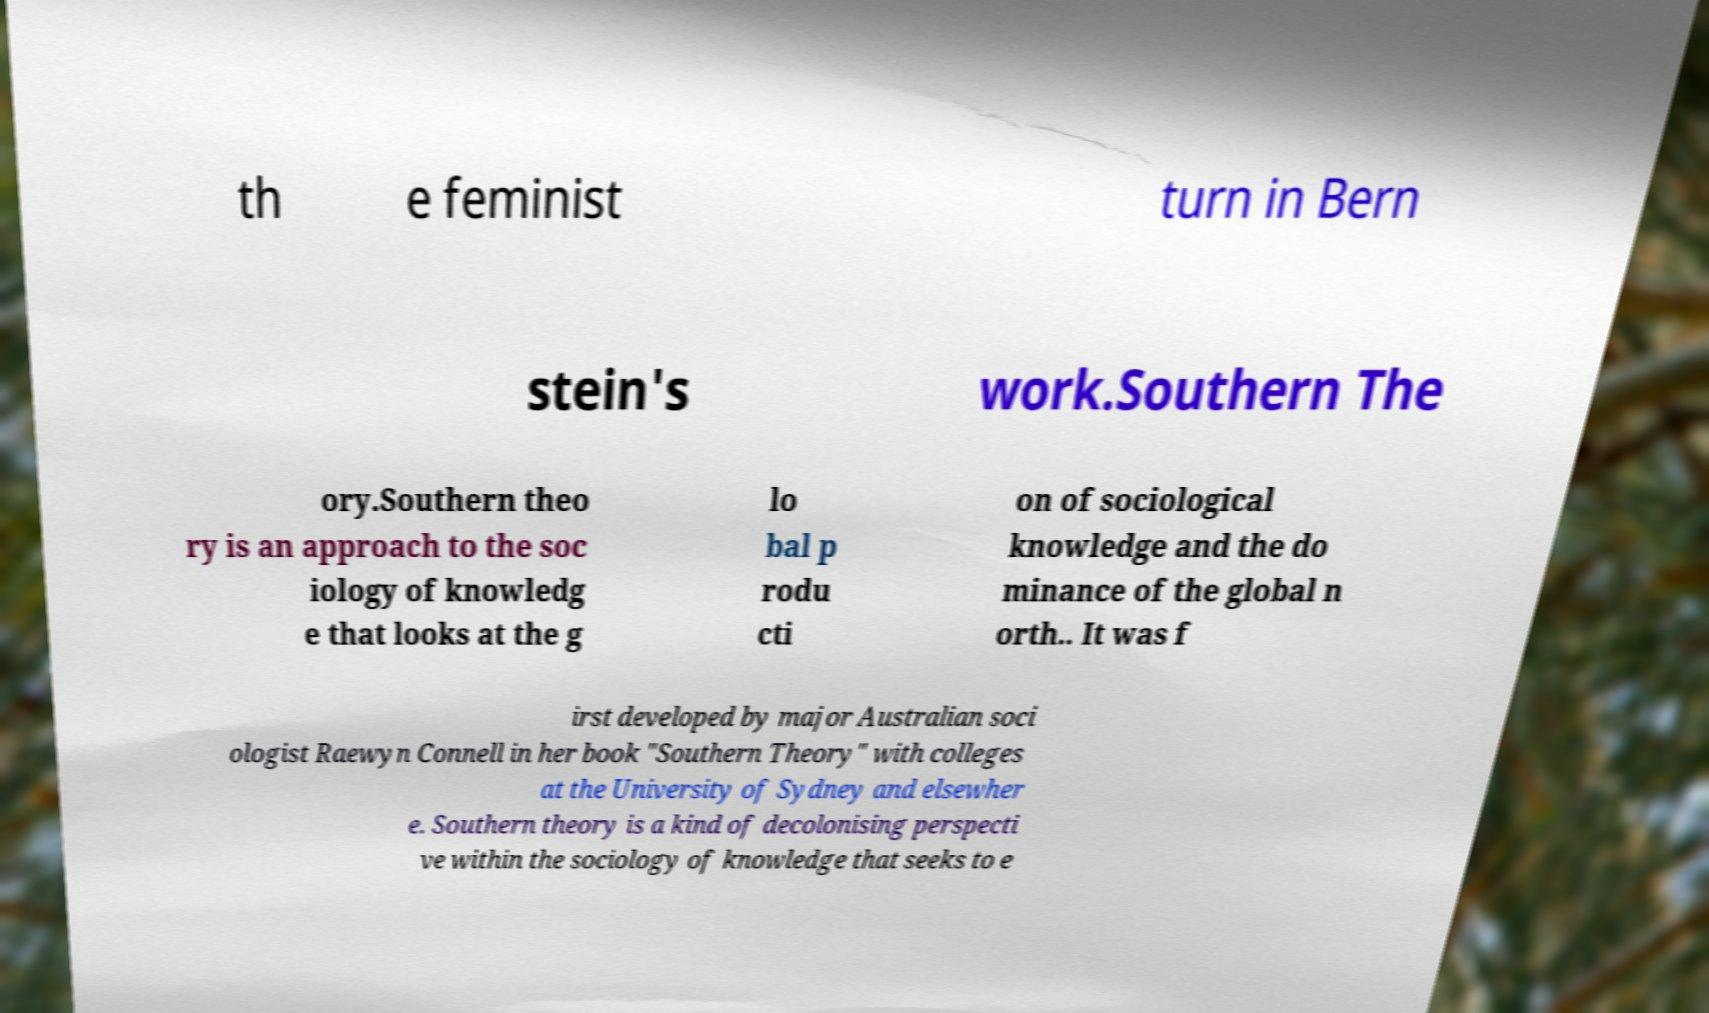What messages or text are displayed in this image? I need them in a readable, typed format. th e feminist turn in Bern stein's work.Southern The ory.Southern theo ry is an approach to the soc iology of knowledg e that looks at the g lo bal p rodu cti on of sociological knowledge and the do minance of the global n orth.. It was f irst developed by major Australian soci ologist Raewyn Connell in her book "Southern Theory" with colleges at the University of Sydney and elsewher e. Southern theory is a kind of decolonising perspecti ve within the sociology of knowledge that seeks to e 